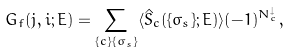<formula> <loc_0><loc_0><loc_500><loc_500>G _ { f } ( j , i ; E ) = \sum _ { \{ c \} \{ \sigma _ { s } \} } \langle \hat { S } _ { c } ( \{ \sigma _ { s } \} ; E ) \rangle ( - 1 ) ^ { N _ { c } ^ { \downarrow } } ,</formula> 